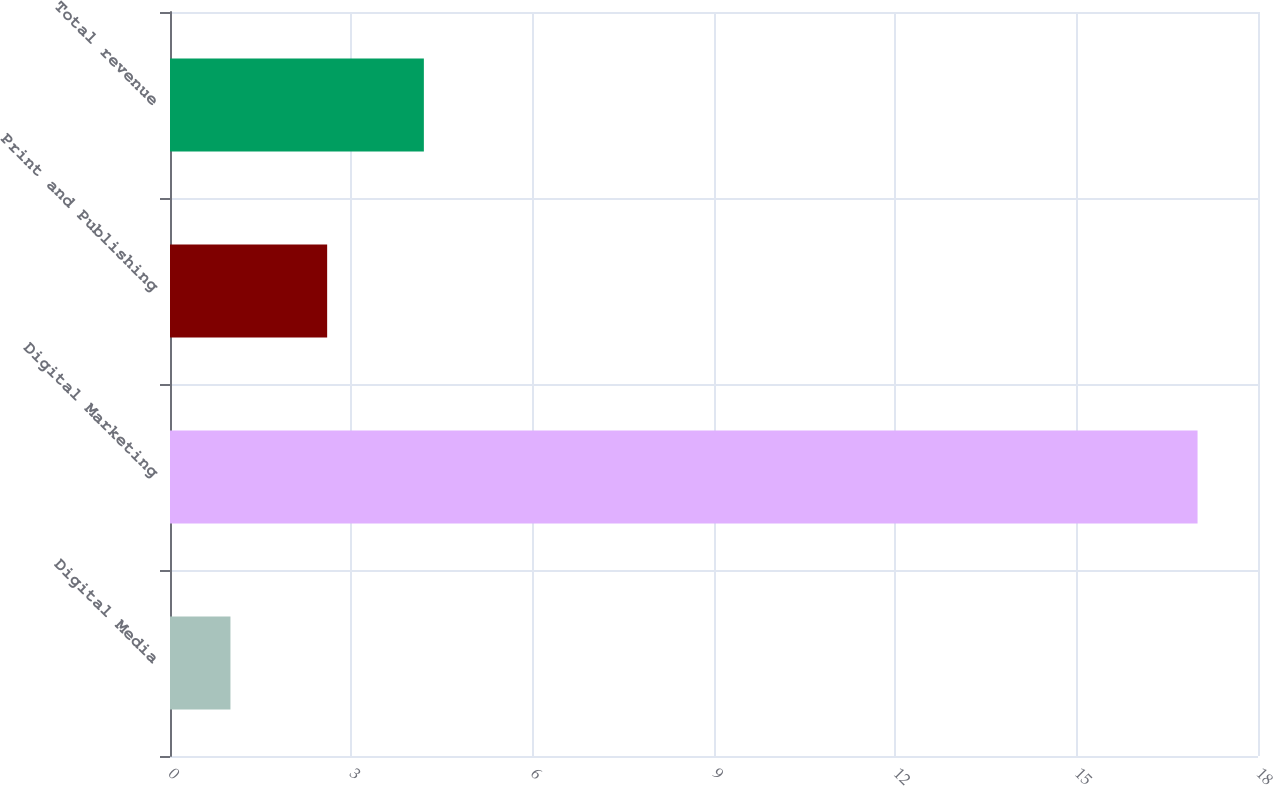<chart> <loc_0><loc_0><loc_500><loc_500><bar_chart><fcel>Digital Media<fcel>Digital Marketing<fcel>Print and Publishing<fcel>Total revenue<nl><fcel>1<fcel>17<fcel>2.6<fcel>4.2<nl></chart> 